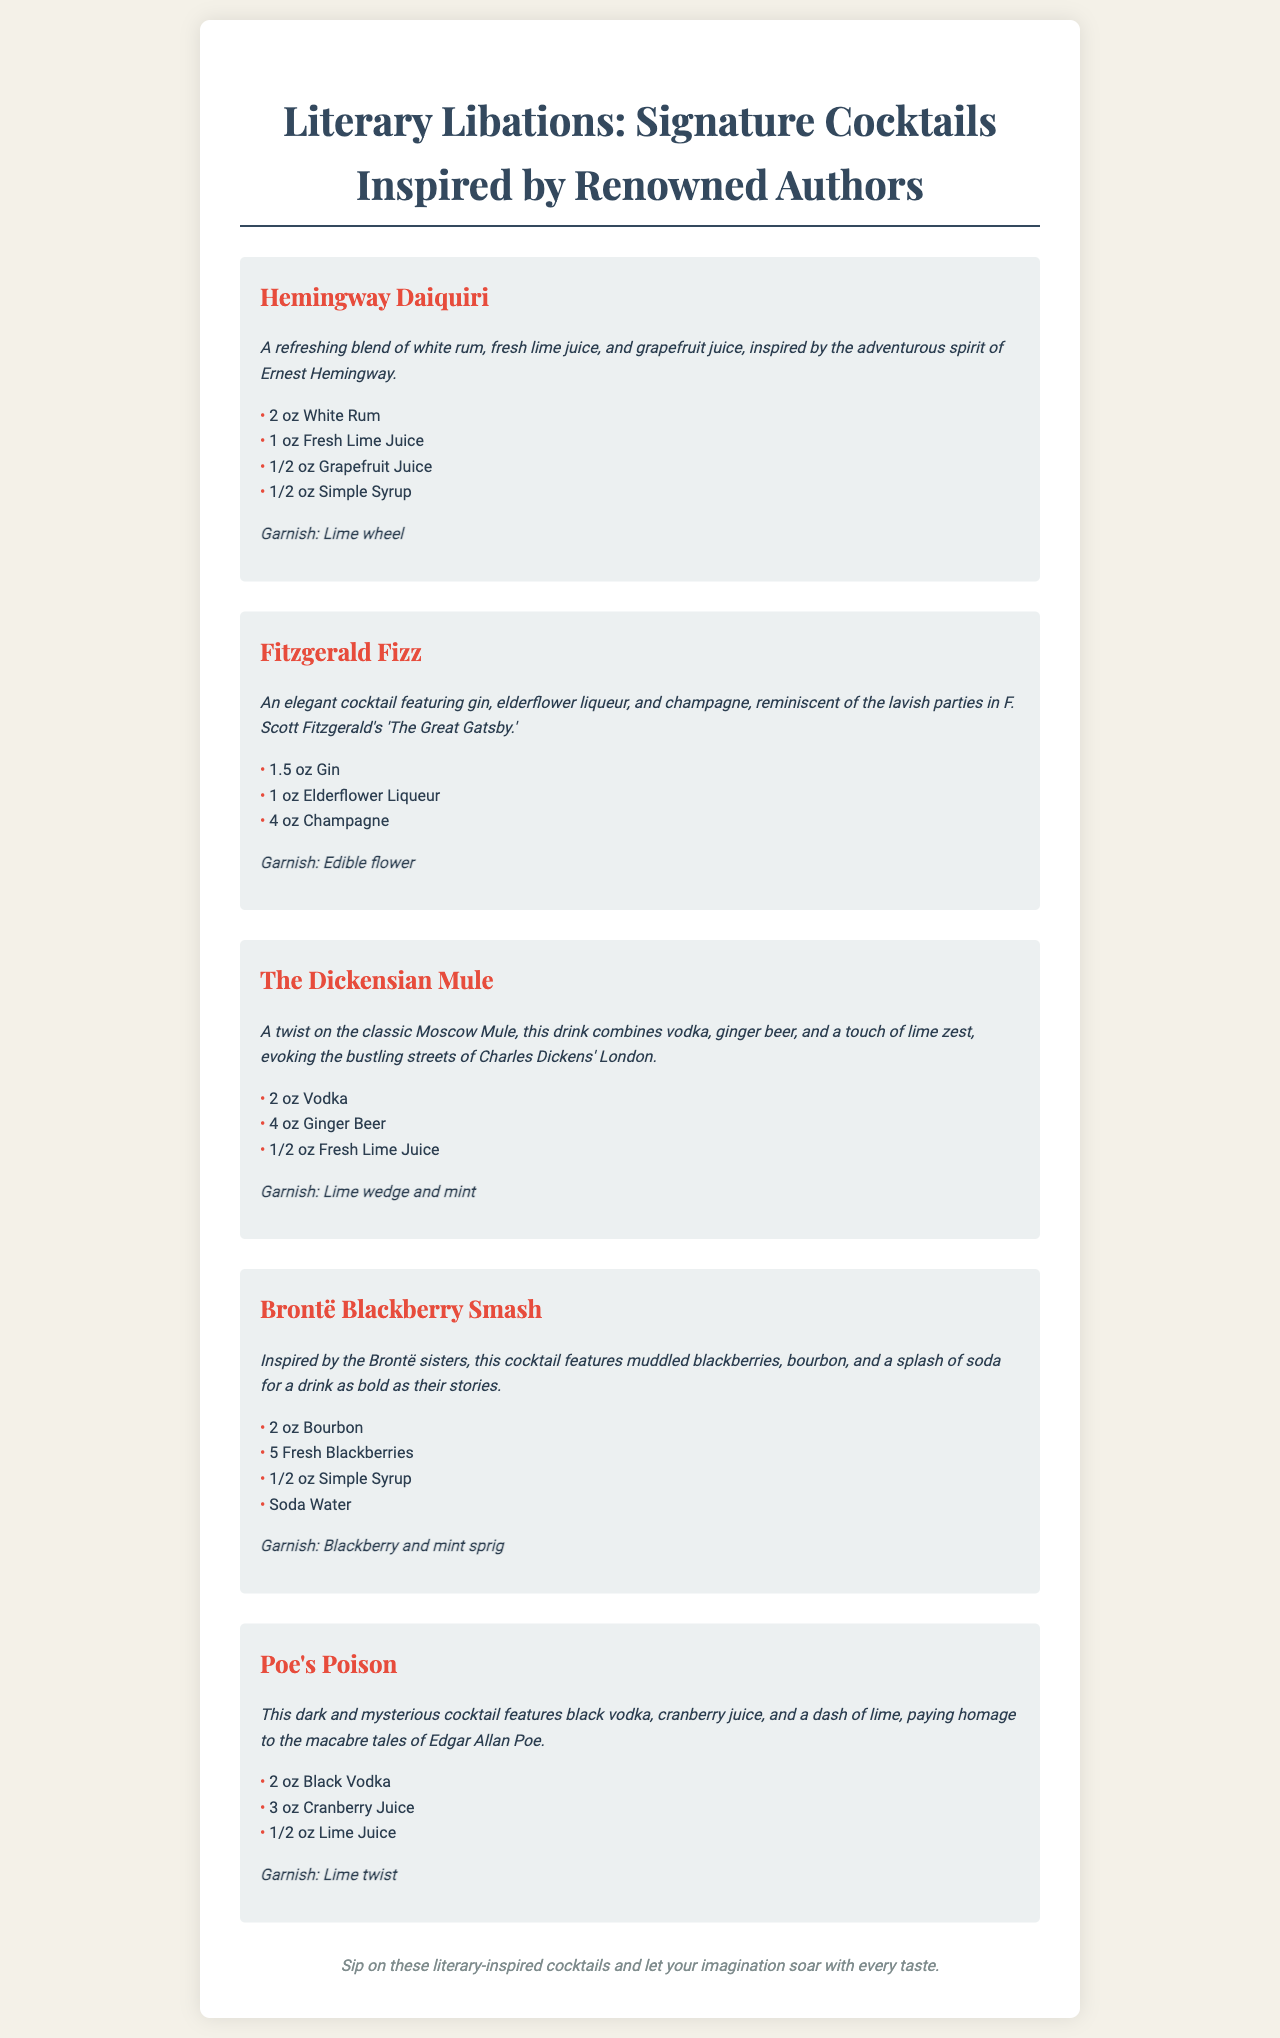What is the first cocktail listed? The first cocktail listed in the menu is the Hemingway Daiquiri.
Answer: Hemingway Daiquiri How many ounces of fresh lime juice are in the Fitzgerald Fizz? The Fitzgerald Fizz contains 1 ounce of fresh lime juice.
Answer: 1 oz What type of vodka is used in Poe's Poison? The type of vodka used in Poe's Poison is black vodka.
Answer: Black Vodka Which cocktail features muddled blackberries? The cocktail that features muddled blackberries is the Brontë Blackberry Smash.
Answer: Brontë Blackberry Smash What is the garnish for The Dickensian Mule? The garnish for The Dickensian Mule is a lime wedge and mint.
Answer: Lime wedge and mint Which cocktail is inspired by F. Scott Fitzgerald? The cocktail inspired by F. Scott Fitzgerald is the Fitzgerald Fizz.
Answer: Fitzgerald Fizz How many ingredients are in the Hemingway Daiquiri? The Hemingway Daiquiri has 4 listed ingredients.
Answer: 4 What is the garnish for Poe's Poison? The garnish for Poe's Poison is a lime twist.
Answer: Lime twist Which cocktail has champagne as an ingredient? The cocktail that has champagne as an ingredient is the Fitzgerald Fizz.
Answer: Fitzgerald Fizz 